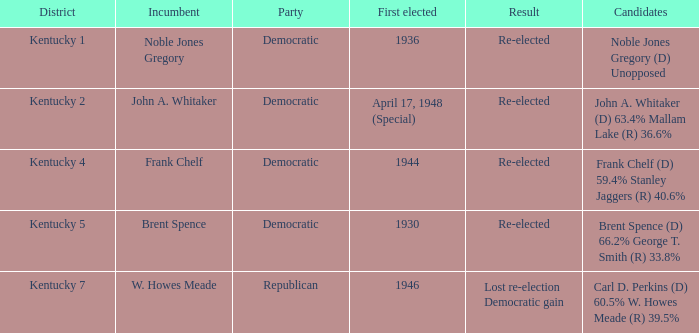Who were the aspirants in the kentucky 4 voting region? Frank Chelf (D) 59.4% Stanley Jaggers (R) 40.6%. 